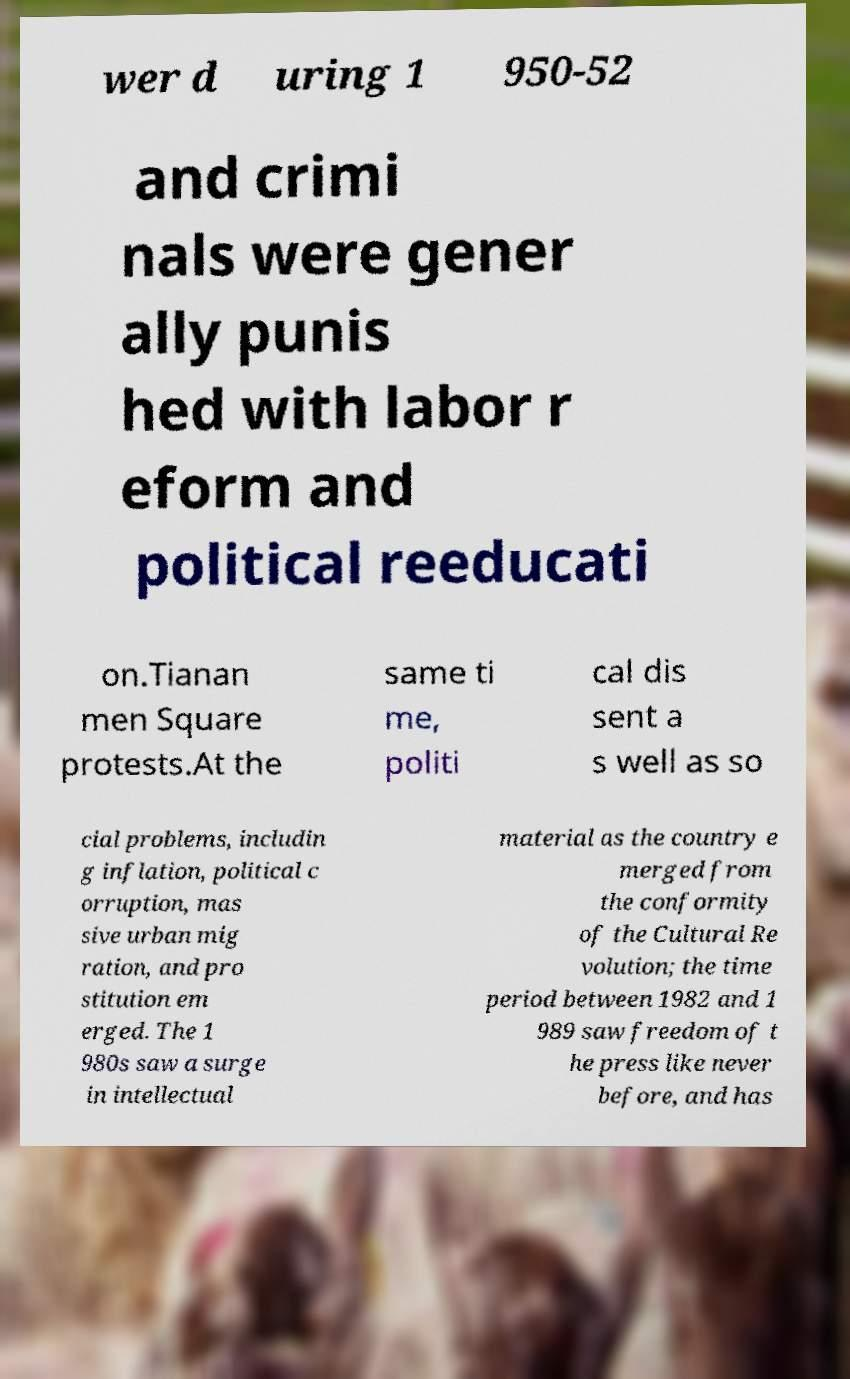Could you extract and type out the text from this image? wer d uring 1 950-52 and crimi nals were gener ally punis hed with labor r eform and political reeducati on.Tianan men Square protests.At the same ti me, politi cal dis sent a s well as so cial problems, includin g inflation, political c orruption, mas sive urban mig ration, and pro stitution em erged. The 1 980s saw a surge in intellectual material as the country e merged from the conformity of the Cultural Re volution; the time period between 1982 and 1 989 saw freedom of t he press like never before, and has 